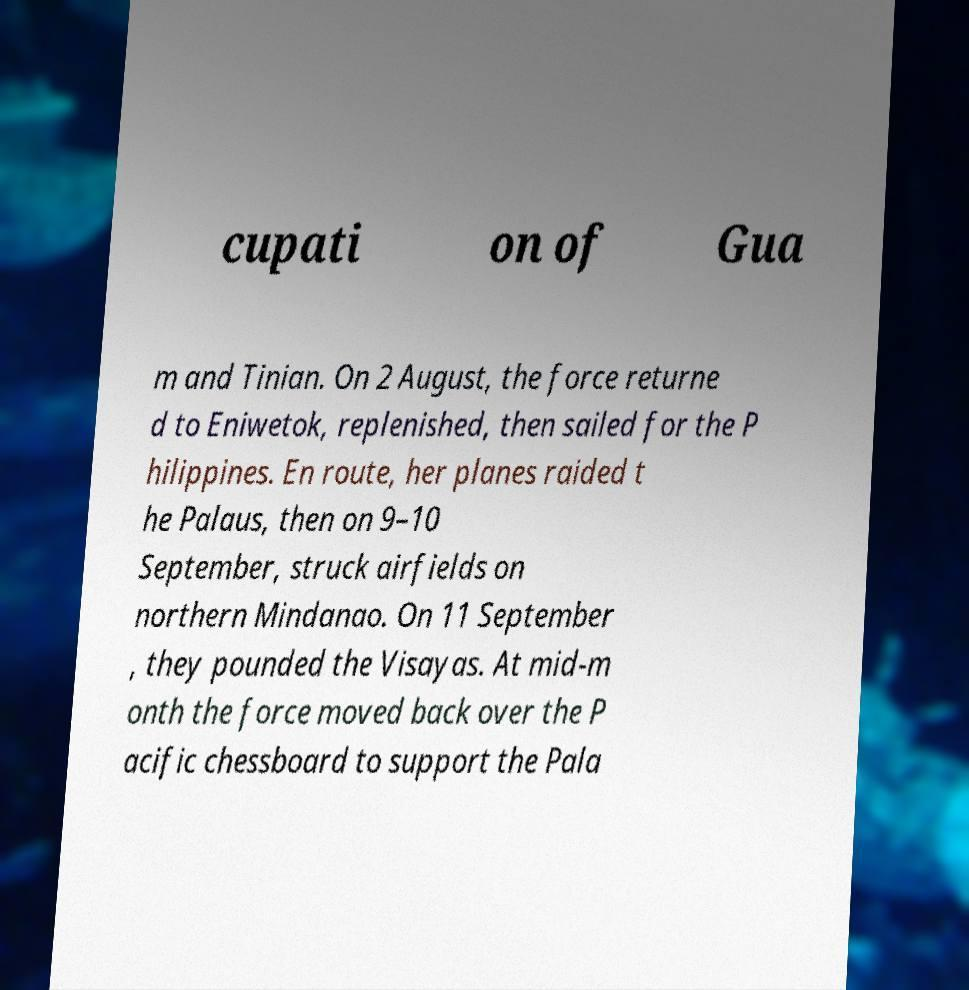Please identify and transcribe the text found in this image. cupati on of Gua m and Tinian. On 2 August, the force returne d to Eniwetok, replenished, then sailed for the P hilippines. En route, her planes raided t he Palaus, then on 9–10 September, struck airfields on northern Mindanao. On 11 September , they pounded the Visayas. At mid-m onth the force moved back over the P acific chessboard to support the Pala 